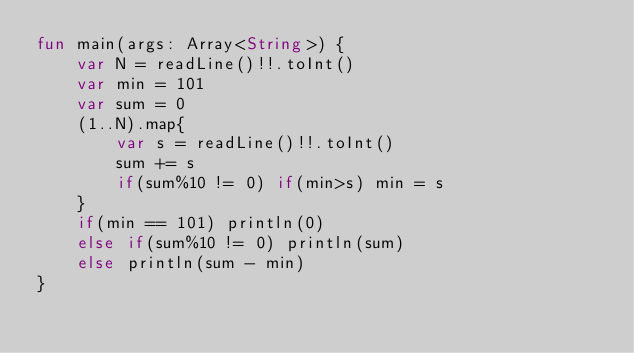Convert code to text. <code><loc_0><loc_0><loc_500><loc_500><_Kotlin_>fun main(args: Array<String>) {
    var N = readLine()!!.toInt()
    var min = 101
    var sum = 0
    (1..N).map{
        var s = readLine()!!.toInt()
        sum += s
        if(sum%10 != 0) if(min>s) min = s
    }
    if(min == 101) println(0)
    else if(sum%10 != 0) println(sum)
    else println(sum - min)
}
</code> 